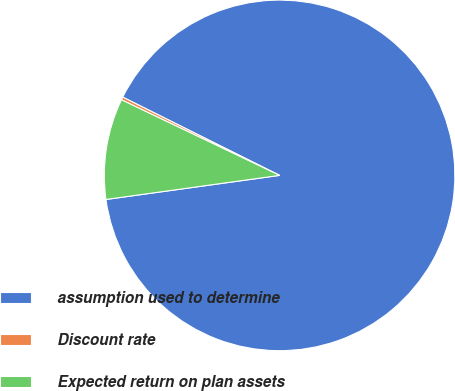Convert chart. <chart><loc_0><loc_0><loc_500><loc_500><pie_chart><fcel>assumption used to determine<fcel>Discount rate<fcel>Expected return on plan assets<nl><fcel>90.44%<fcel>0.27%<fcel>9.29%<nl></chart> 